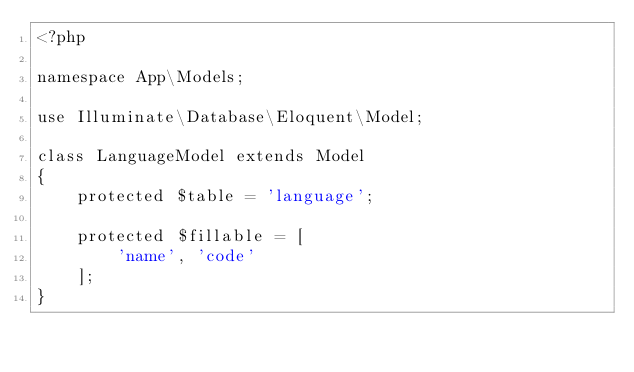<code> <loc_0><loc_0><loc_500><loc_500><_PHP_><?php

namespace App\Models;

use Illuminate\Database\Eloquent\Model;

class LanguageModel extends Model
{
    protected $table = 'language';

    protected $fillable = [
        'name', 'code'
    ];
}
</code> 